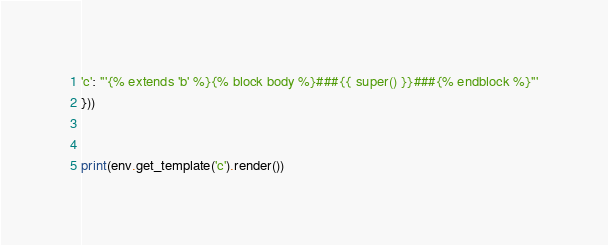<code> <loc_0><loc_0><loc_500><loc_500><_Python_>'c': '''{% extends 'b' %}{% block body %}###{{ super() }}###{% endblock %}'''
}))


print(env.get_template('c').render())
</code> 